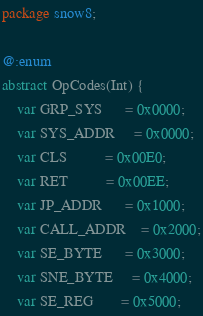Convert code to text. <code><loc_0><loc_0><loc_500><loc_500><_Haxe_>package snow8;

@:enum
abstract OpCodes(Int) {
	var GRP_SYS      = 0x0000;
	var SYS_ADDR     = 0x0000;
	var CLS          = 0x00E0;
	var RET          = 0x00EE;
	var JP_ADDR      = 0x1000;
	var CALL_ADDR    = 0x2000;
	var SE_BYTE      = 0x3000;
	var SNE_BYTE     = 0x4000;
	var SE_REG       = 0x5000;</code> 